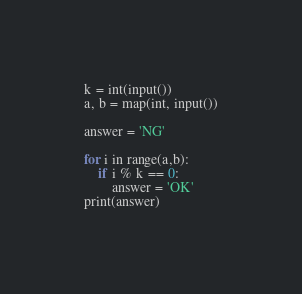Convert code to text. <code><loc_0><loc_0><loc_500><loc_500><_Python_>k = int(input())
a, b = map(int, input())

answer = 'NG'

for i in range(a,b):
    if i % k == 0:
        answer = 'OK'
print(answer)

</code> 